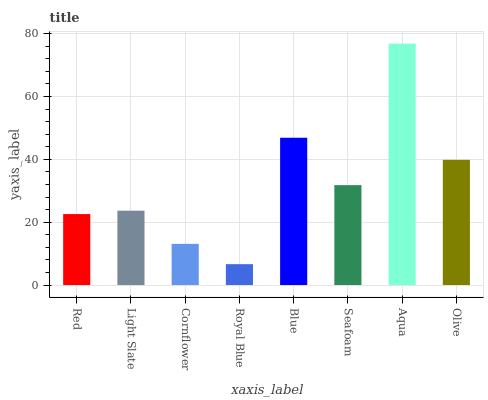Is Royal Blue the minimum?
Answer yes or no. Yes. Is Aqua the maximum?
Answer yes or no. Yes. Is Light Slate the minimum?
Answer yes or no. No. Is Light Slate the maximum?
Answer yes or no. No. Is Light Slate greater than Red?
Answer yes or no. Yes. Is Red less than Light Slate?
Answer yes or no. Yes. Is Red greater than Light Slate?
Answer yes or no. No. Is Light Slate less than Red?
Answer yes or no. No. Is Seafoam the high median?
Answer yes or no. Yes. Is Light Slate the low median?
Answer yes or no. Yes. Is Light Slate the high median?
Answer yes or no. No. Is Olive the low median?
Answer yes or no. No. 